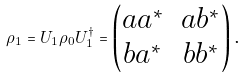Convert formula to latex. <formula><loc_0><loc_0><loc_500><loc_500>\rho _ { 1 } = U _ { 1 } \rho _ { 0 } U _ { 1 } ^ { \dag } = \begin{pmatrix} a a ^ { * } & a b ^ { * } \\ b a ^ { * } & b b ^ { * } \\ \end{pmatrix} \text {.}</formula> 